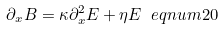Convert formula to latex. <formula><loc_0><loc_0><loc_500><loc_500>\partial _ { x } B = \kappa \partial _ { x } ^ { 2 } E + \eta E \ e q n u m { 2 0 }</formula> 